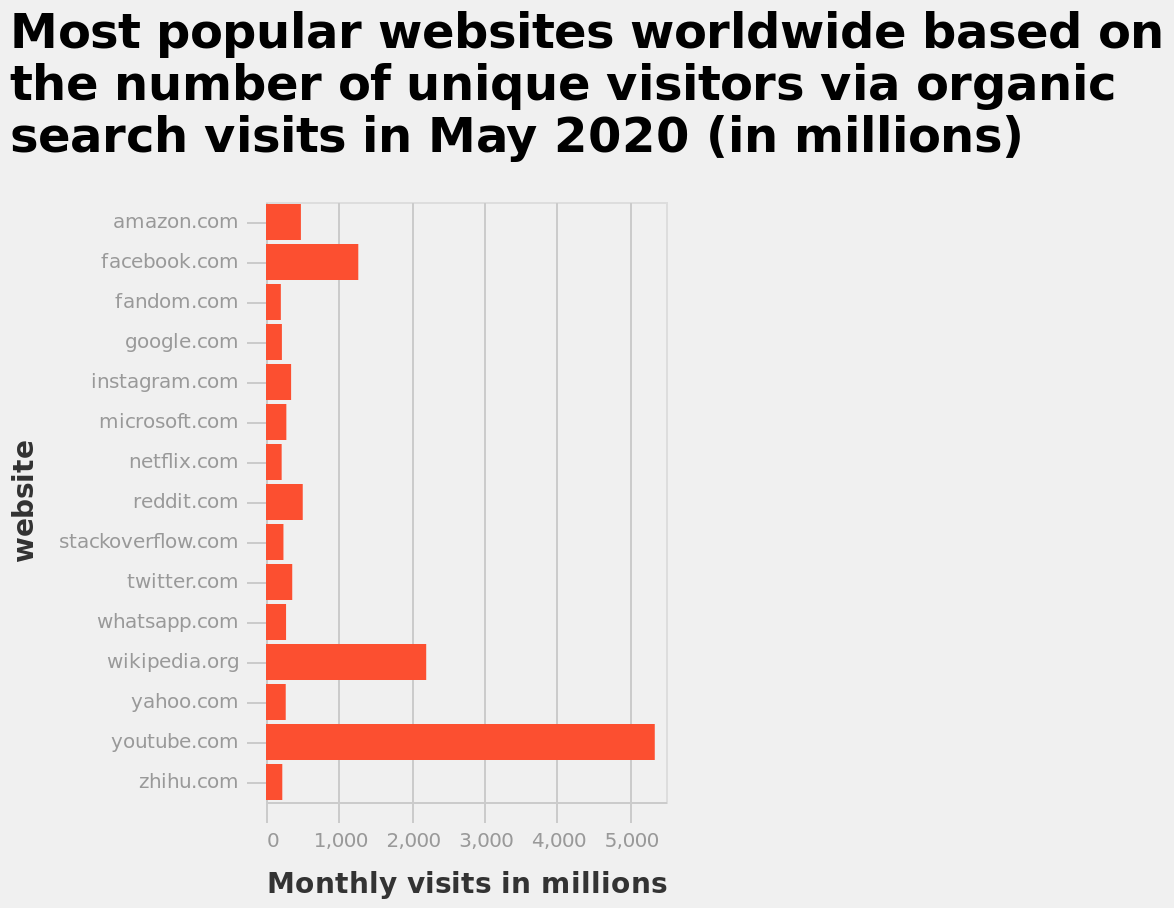<image>
Can you name the top three websites with the highest number of monthly visits? The top three websites with the highest number of monthly visits are YouTube, Wikipedia, and Facebook. Describe the following image in detail Most popular websites worldwide based on the number of unique visitors via organic search visits in May 2020 (in millions) is a bar graph. website is measured along a categorical scale with amazon.com on one end and zhihu.com at the other along the y-axis. A linear scale of range 0 to 5,000 can be found along the x-axis, marked Monthly visits in millions. What does the x-axis on the bar graph represent? The x-axis on the bar graph represents the monthly visits in millions. How many monthly visitors does YouTube have? YouTube has approximately 5,400 visitors per month. 